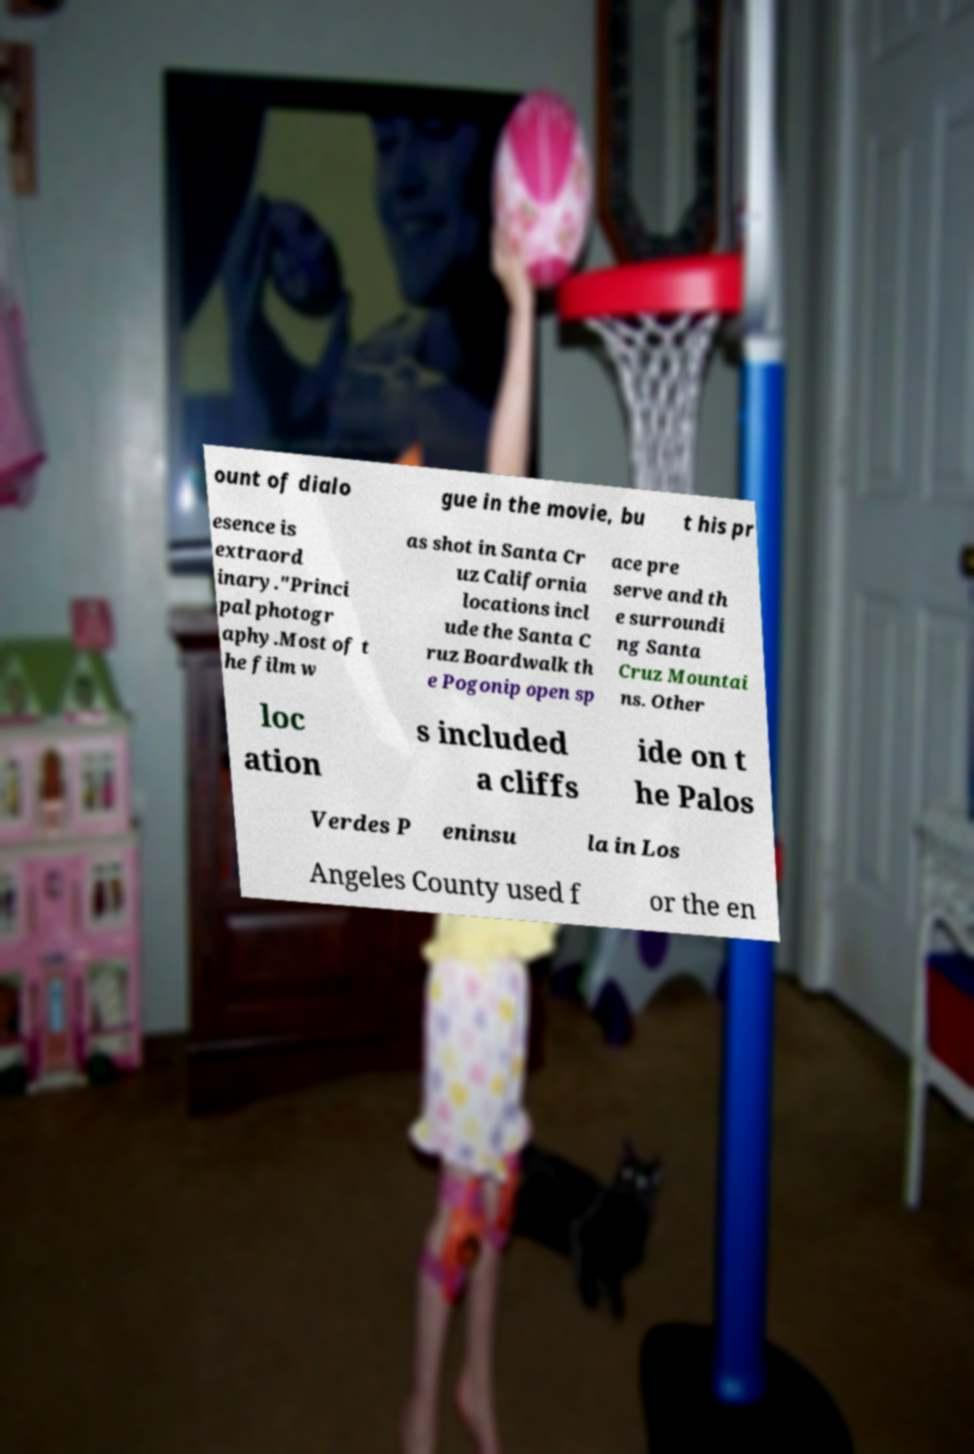For documentation purposes, I need the text within this image transcribed. Could you provide that? ount of dialo gue in the movie, bu t his pr esence is extraord inary."Princi pal photogr aphy.Most of t he film w as shot in Santa Cr uz California locations incl ude the Santa C ruz Boardwalk th e Pogonip open sp ace pre serve and th e surroundi ng Santa Cruz Mountai ns. Other loc ation s included a cliffs ide on t he Palos Verdes P eninsu la in Los Angeles County used f or the en 